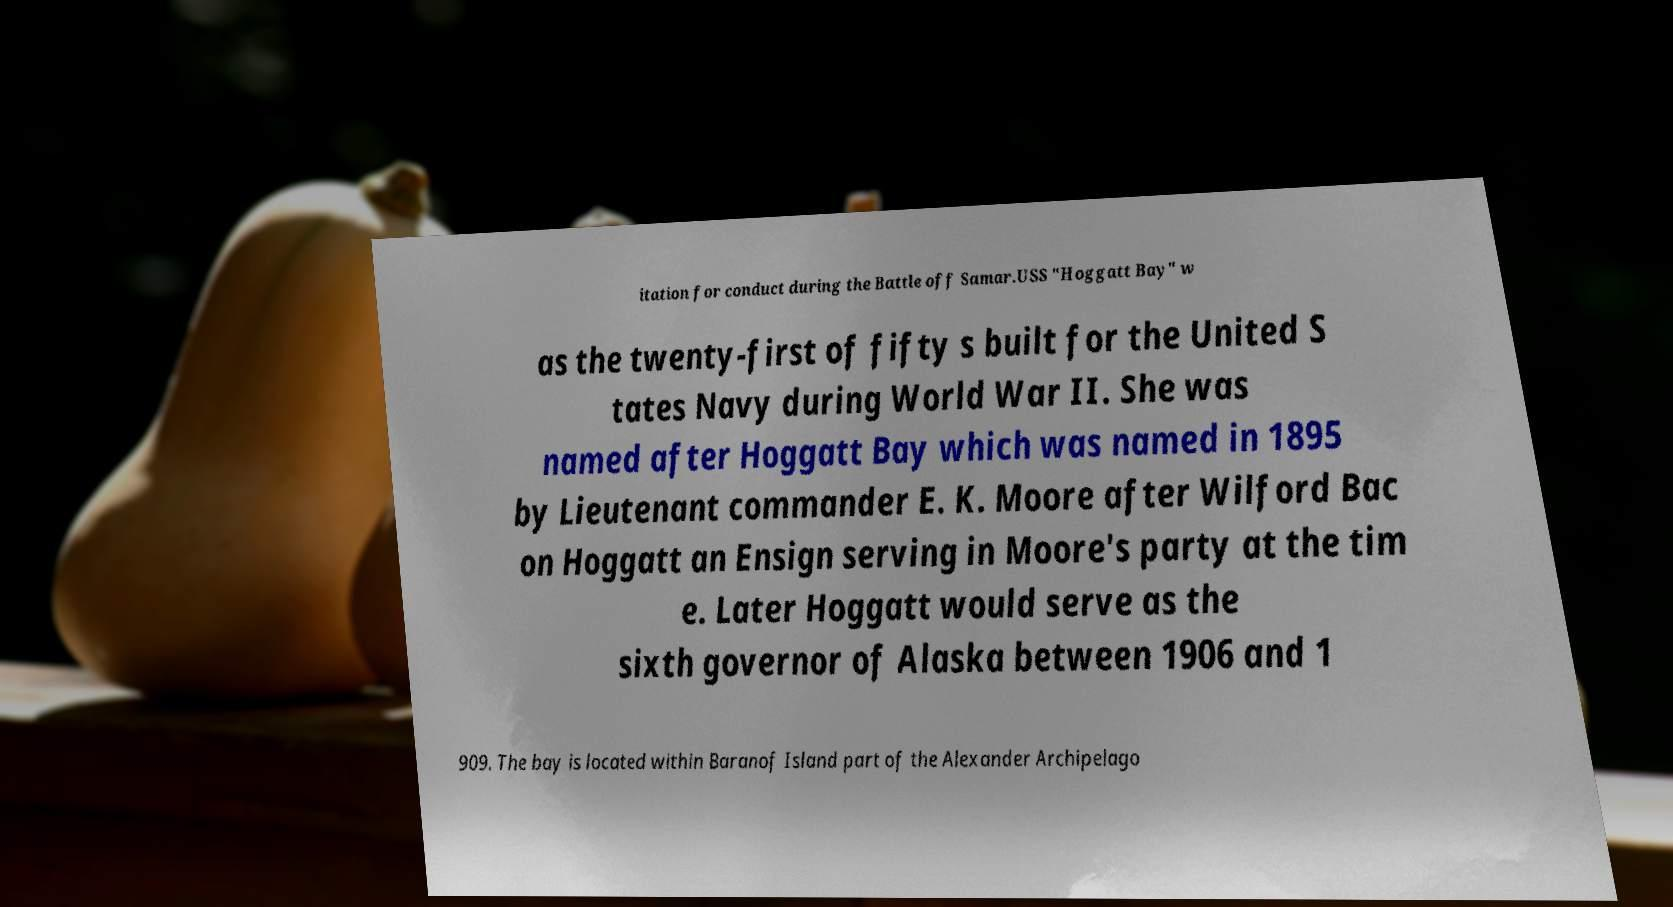Can you read and provide the text displayed in the image?This photo seems to have some interesting text. Can you extract and type it out for me? itation for conduct during the Battle off Samar.USS "Hoggatt Bay" w as the twenty-first of fifty s built for the United S tates Navy during World War II. She was named after Hoggatt Bay which was named in 1895 by Lieutenant commander E. K. Moore after Wilford Bac on Hoggatt an Ensign serving in Moore's party at the tim e. Later Hoggatt would serve as the sixth governor of Alaska between 1906 and 1 909. The bay is located within Baranof Island part of the Alexander Archipelago 